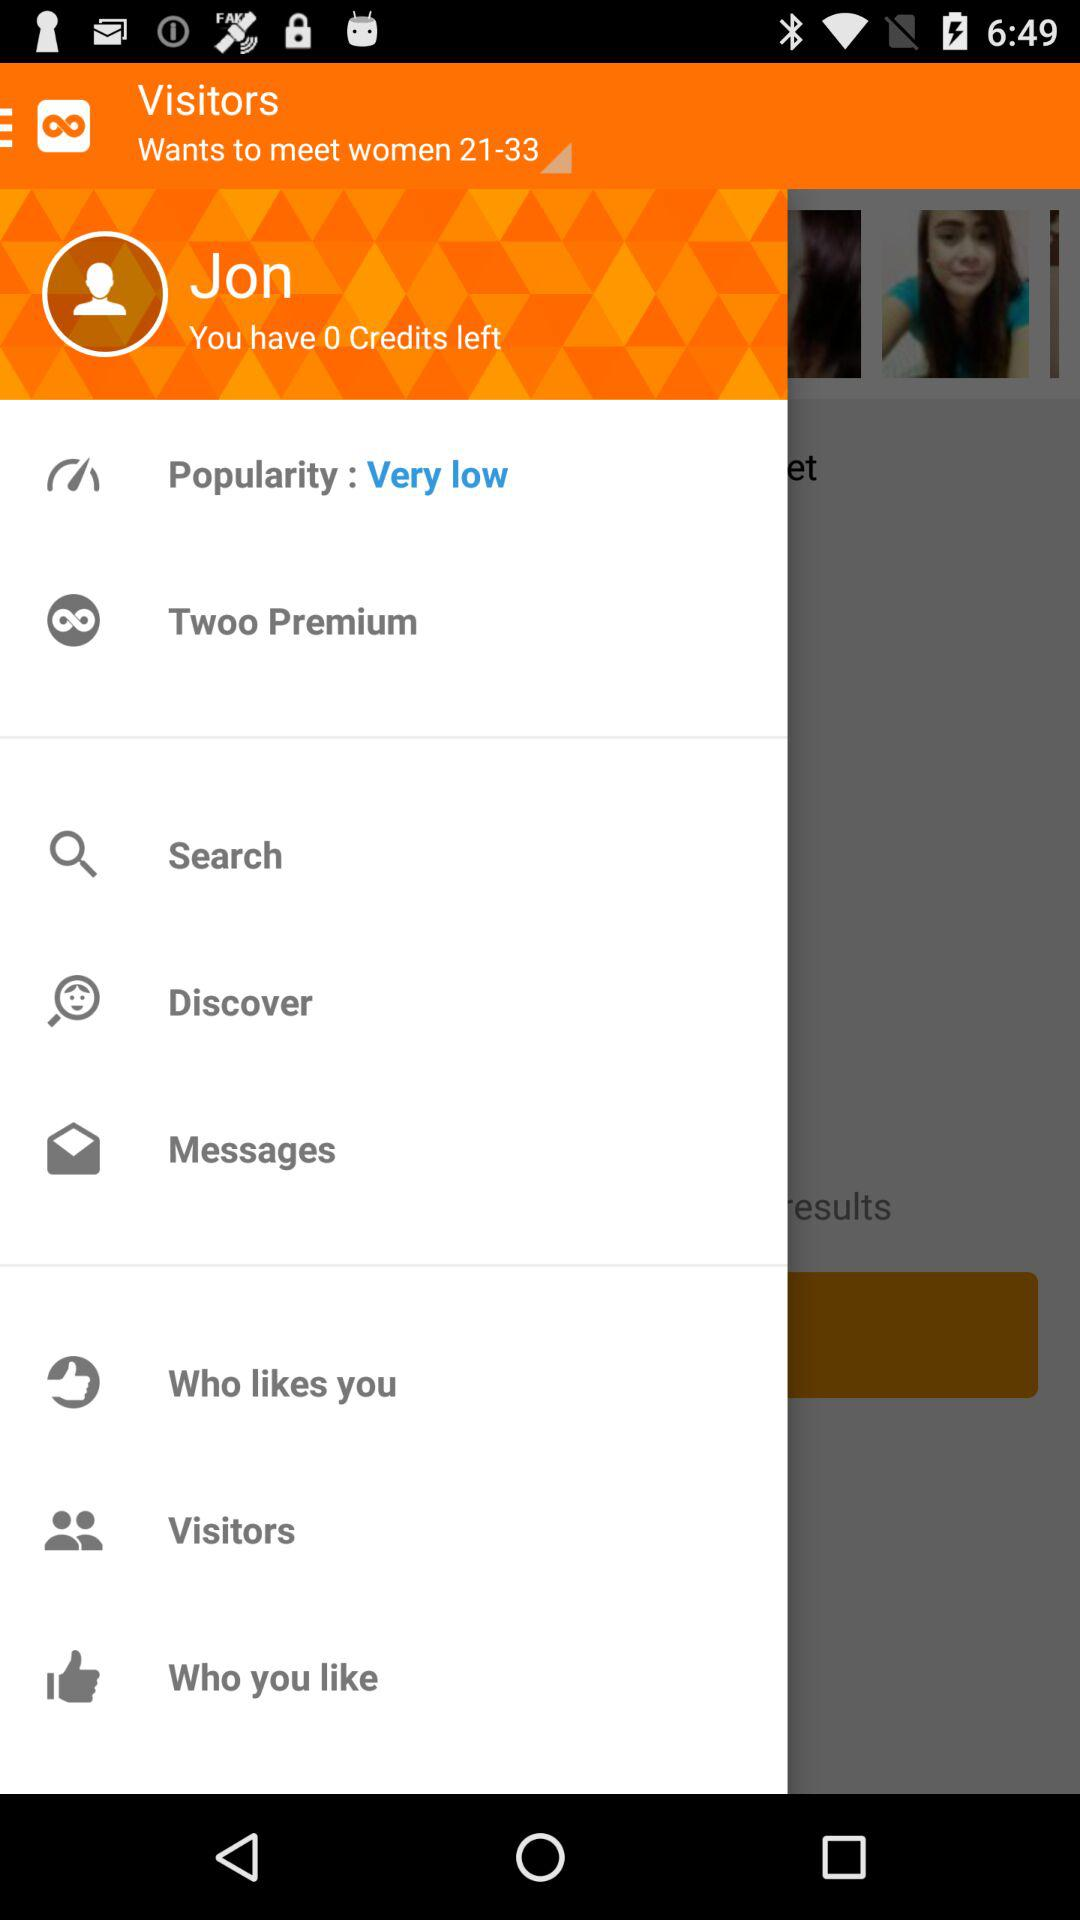How many unread messages are there?
When the provided information is insufficient, respond with <no answer>. <no answer> 